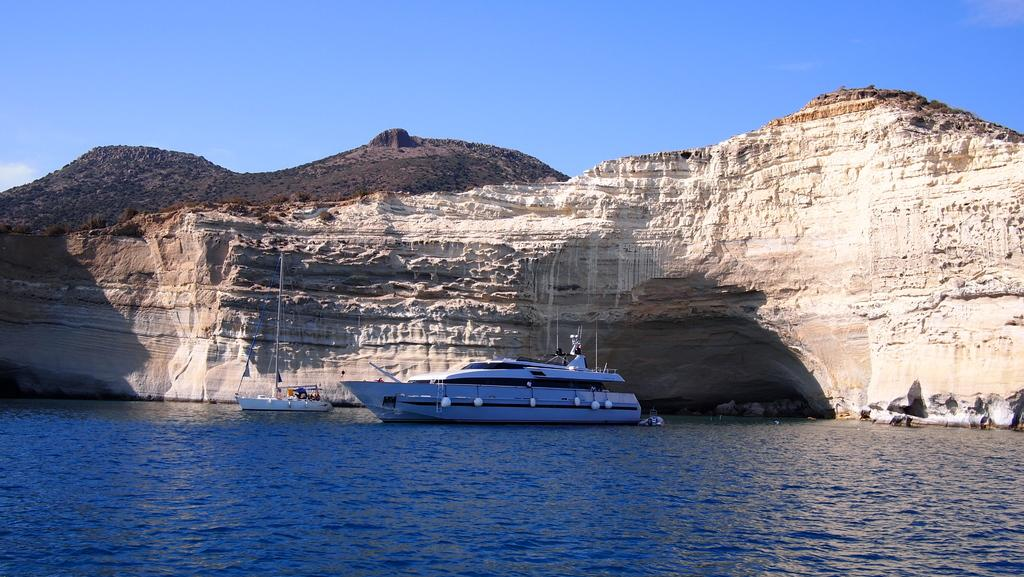What is the main subject in the image? There is a ship in the image. What else is present on the water in the image? There is a boat on the surface of water in the image. What can be seen in the background of the image? There is a mountain in the background of the image. What is the color of the sky in the image? The sky is blue and visible at the top of the image. Can you tell me how many horses are present in the image? There are no horses present in the image. What type of holiday is being celebrated in the image? There is no indication of a holiday being celebrated in the image. 